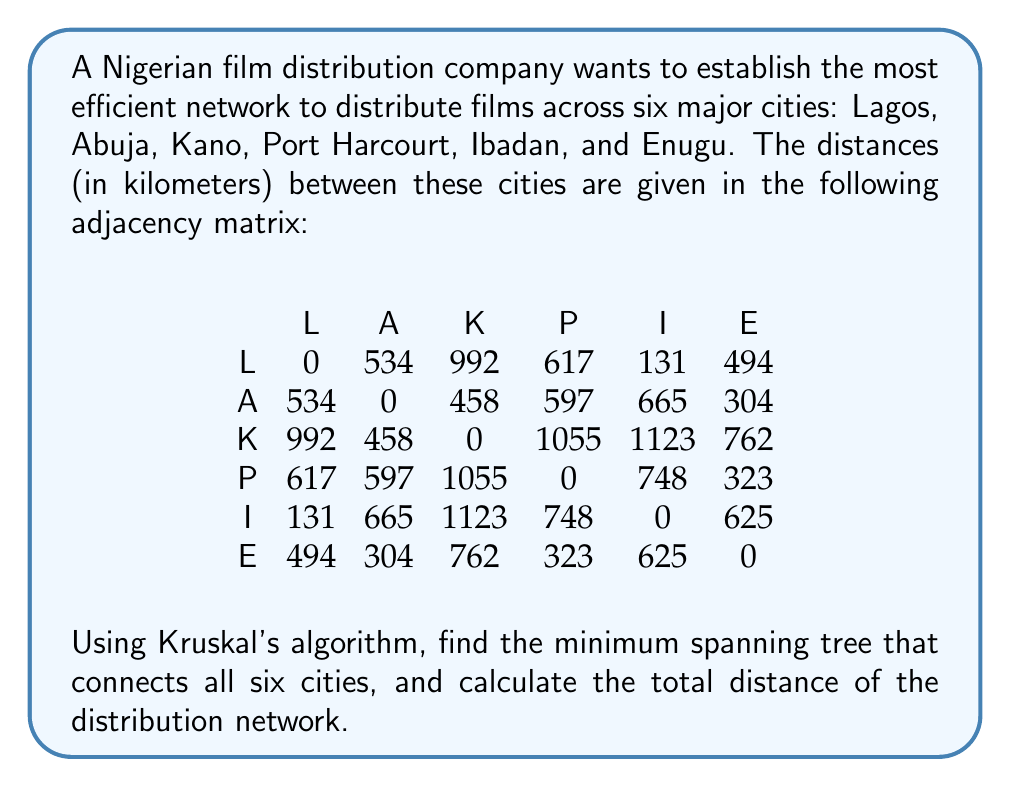Solve this math problem. To solve this problem, we'll use Kruskal's algorithm to find the minimum spanning tree (MST) of the given graph. This will give us the shortest path for the film distribution network. Here's the step-by-step process:

1. List all edges and their weights (distances) in ascending order:
   - Ibadan - Lagos: 131 km
   - Abuja - Enugu: 304 km
   - Port Harcourt - Enugu: 323 km
   - Lagos - Enugu: 494 km
   - Abuja - Kano: 458 km
   - Lagos - Abuja: 534 km
   - Lagos - Port Harcourt: 617 km
   - Ibadan - Enugu: 625 km
   - Abuja - Port Harcourt: 597 km
   - Ibadan - Port Harcourt: 748 km
   - Kano - Enugu: 762 km
   - Lagos - Kano: 992 km
   - Kano - Port Harcourt: 1055 km
   - Kano - Ibadan: 1123 km

2. Start with an empty graph and add edges in order of increasing weight, skipping any that would create a cycle:
   - Add Ibadan - Lagos (131 km)
   - Add Abuja - Enugu (304 km)
   - Add Port Harcourt - Enugu (323 km)
   - Add Lagos - Enugu (494 km)
   - Add Abuja - Kano (458 km)

3. The algorithm stops here because we have added 5 edges, which is sufficient to connect all 6 vertices in a tree (n-1 edges, where n is the number of vertices).

4. The resulting minimum spanning tree is:
   Ibadan - Lagos - Enugu - Port Harcourt
                  |
                Abuja - Kano

5. Calculate the total distance of the distribution network by summing the distances of the edges in the MST:
   Total distance = 131 + 304 + 323 + 494 + 458 = 1710 km

Therefore, the minimum spanning tree connects all six cities with a total distance of 1710 km for the film distribution network.
Answer: The minimum spanning tree for the film distribution network has a total distance of 1710 km. 